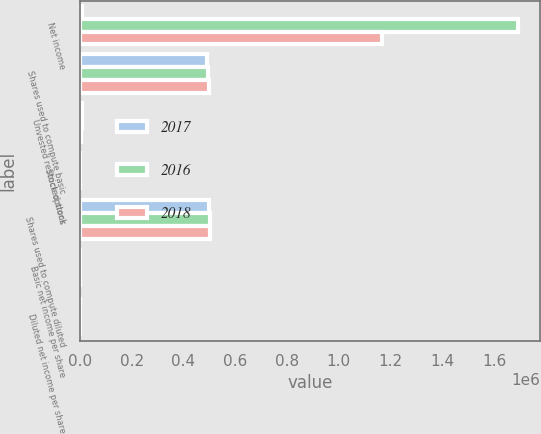Convert chart to OTSL. <chart><loc_0><loc_0><loc_500><loc_500><stacked_bar_chart><ecel><fcel>Net income<fcel>Shares used to compute basic<fcel>Unvested restricted stock<fcel>Stock options<fcel>Shares used to compute diluted<fcel>Basic net income per share<fcel>Diluted net income per share<nl><fcel>2017<fcel>6298.5<fcel>490564<fcel>7142<fcel>137<fcel>497843<fcel>5.28<fcel>5.2<nl><fcel>2016<fcel>1.69395e+06<fcel>493632<fcel>7161<fcel>330<fcel>501123<fcel>3.43<fcel>3.38<nl><fcel>2018<fcel>1.16878e+06<fcel>498345<fcel>5455<fcel>499<fcel>504299<fcel>2.35<fcel>2.32<nl></chart> 